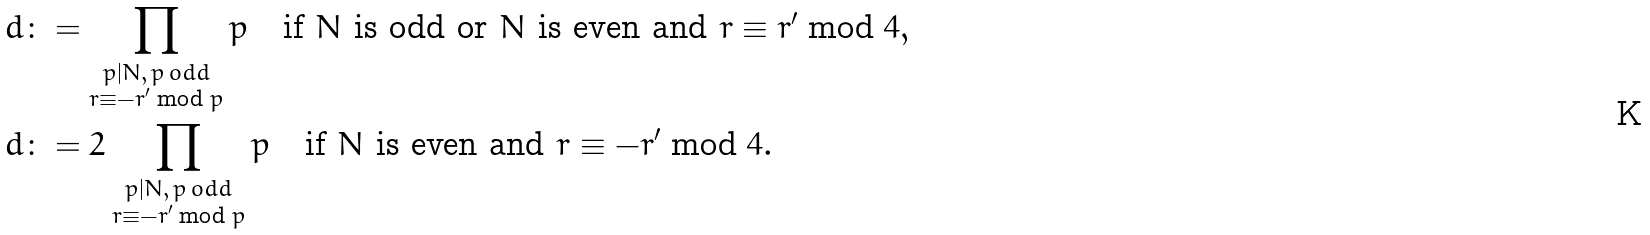<formula> <loc_0><loc_0><loc_500><loc_500>& d \colon = \prod _ { \substack { p | N , \, p \, o d d \\ r \equiv - r ^ { \prime } \bmod { p } } } p \quad \text {if $N$ is odd or $N$ is even and $r\equiv r^{\prime}\bmod{4}$} , \\ & d \colon = 2 \prod _ { \substack { p | N , \, p \, o d d \\ r \equiv - r ^ { \prime } \bmod { p } } } p \quad \text {if $N$ is even and $r\equiv -r^{\prime}\bmod{4}$} .</formula> 